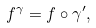Convert formula to latex. <formula><loc_0><loc_0><loc_500><loc_500>f ^ { \gamma } = f \circ \gamma ^ { \prime } ,</formula> 